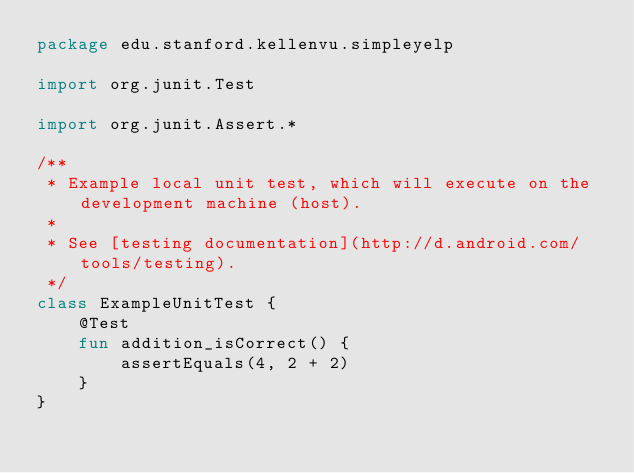<code> <loc_0><loc_0><loc_500><loc_500><_Kotlin_>package edu.stanford.kellenvu.simpleyelp

import org.junit.Test

import org.junit.Assert.*

/**
 * Example local unit test, which will execute on the development machine (host).
 *
 * See [testing documentation](http://d.android.com/tools/testing).
 */
class ExampleUnitTest {
    @Test
    fun addition_isCorrect() {
        assertEquals(4, 2 + 2)
    }
}</code> 